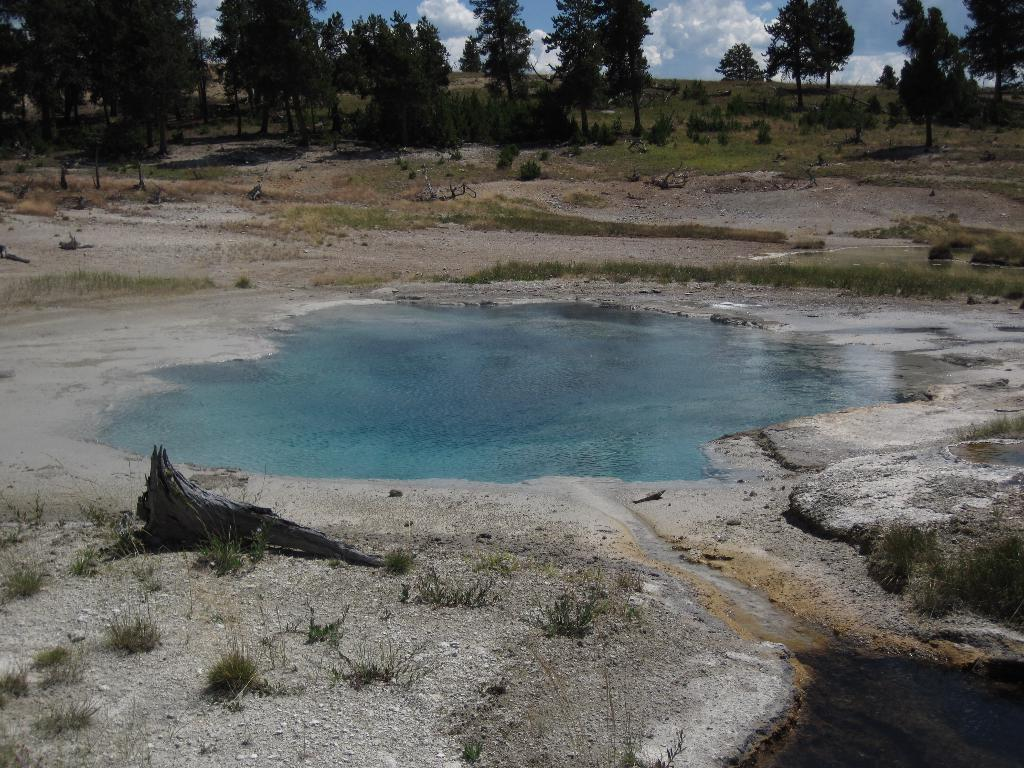What is the main feature in the image? There is a pool of water in the image. What can be seen in the background of the image? There are trees visible behind the water in the image. What type of card is floating on the water in the image? There is no card present in the image; it only features a pool of water and trees in the background. 